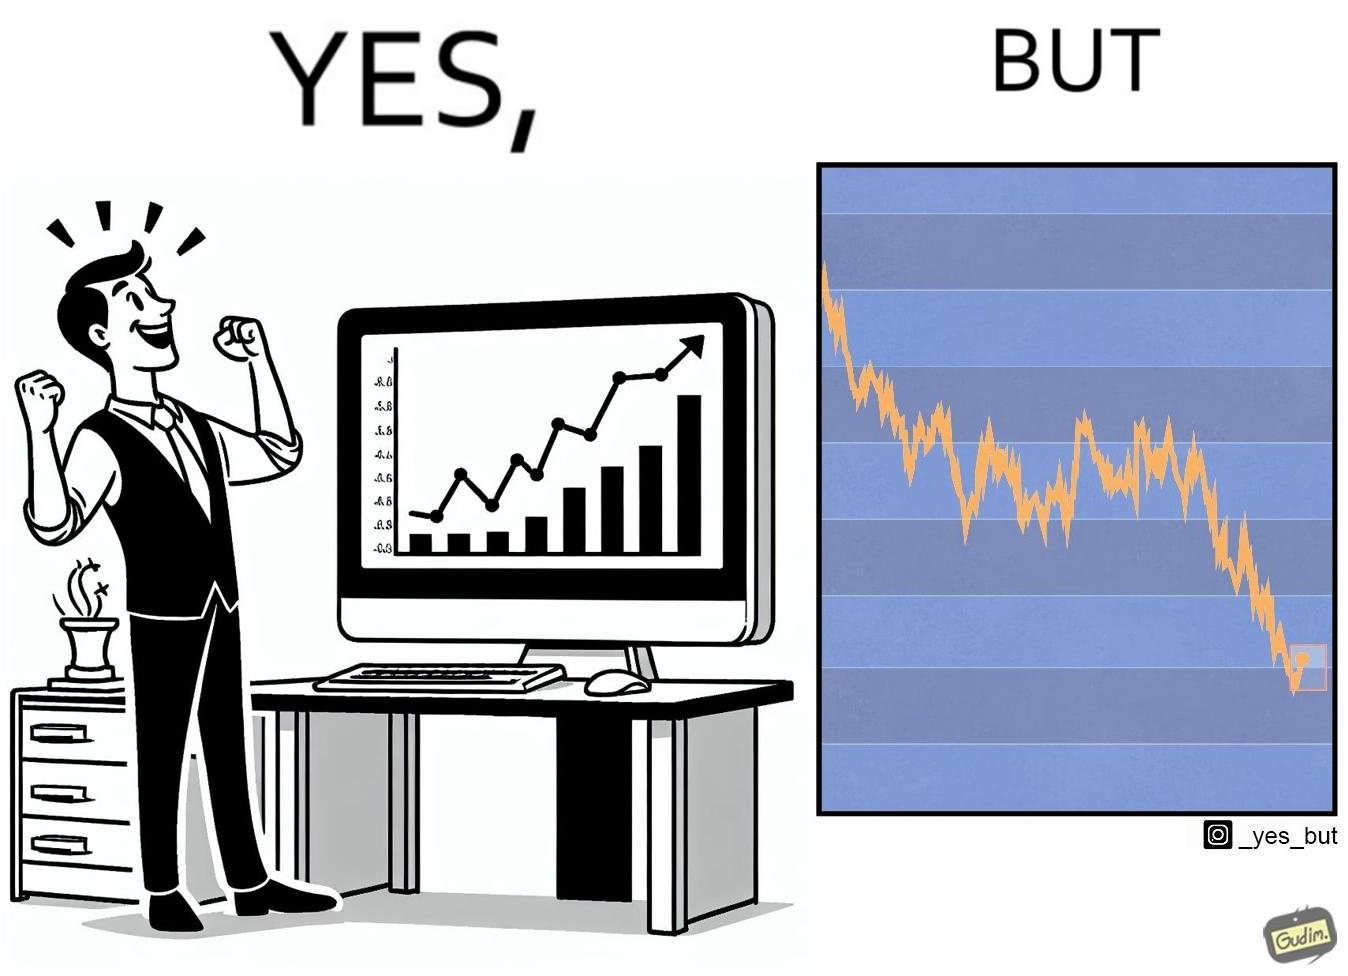Describe the content of this image. The image is ironic, because a person is seen feeling proud over the profit earned over his investment but the right image shows the whole story how only a small part of his investment journey is shown and the other loss part is ignored 